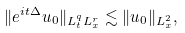<formula> <loc_0><loc_0><loc_500><loc_500>\| e ^ { i t \Delta } u _ { 0 } \| _ { L ^ { q } _ { t } L ^ { r } _ { x } } \lesssim \| u _ { 0 } \| _ { L ^ { 2 } _ { x } } ,</formula> 